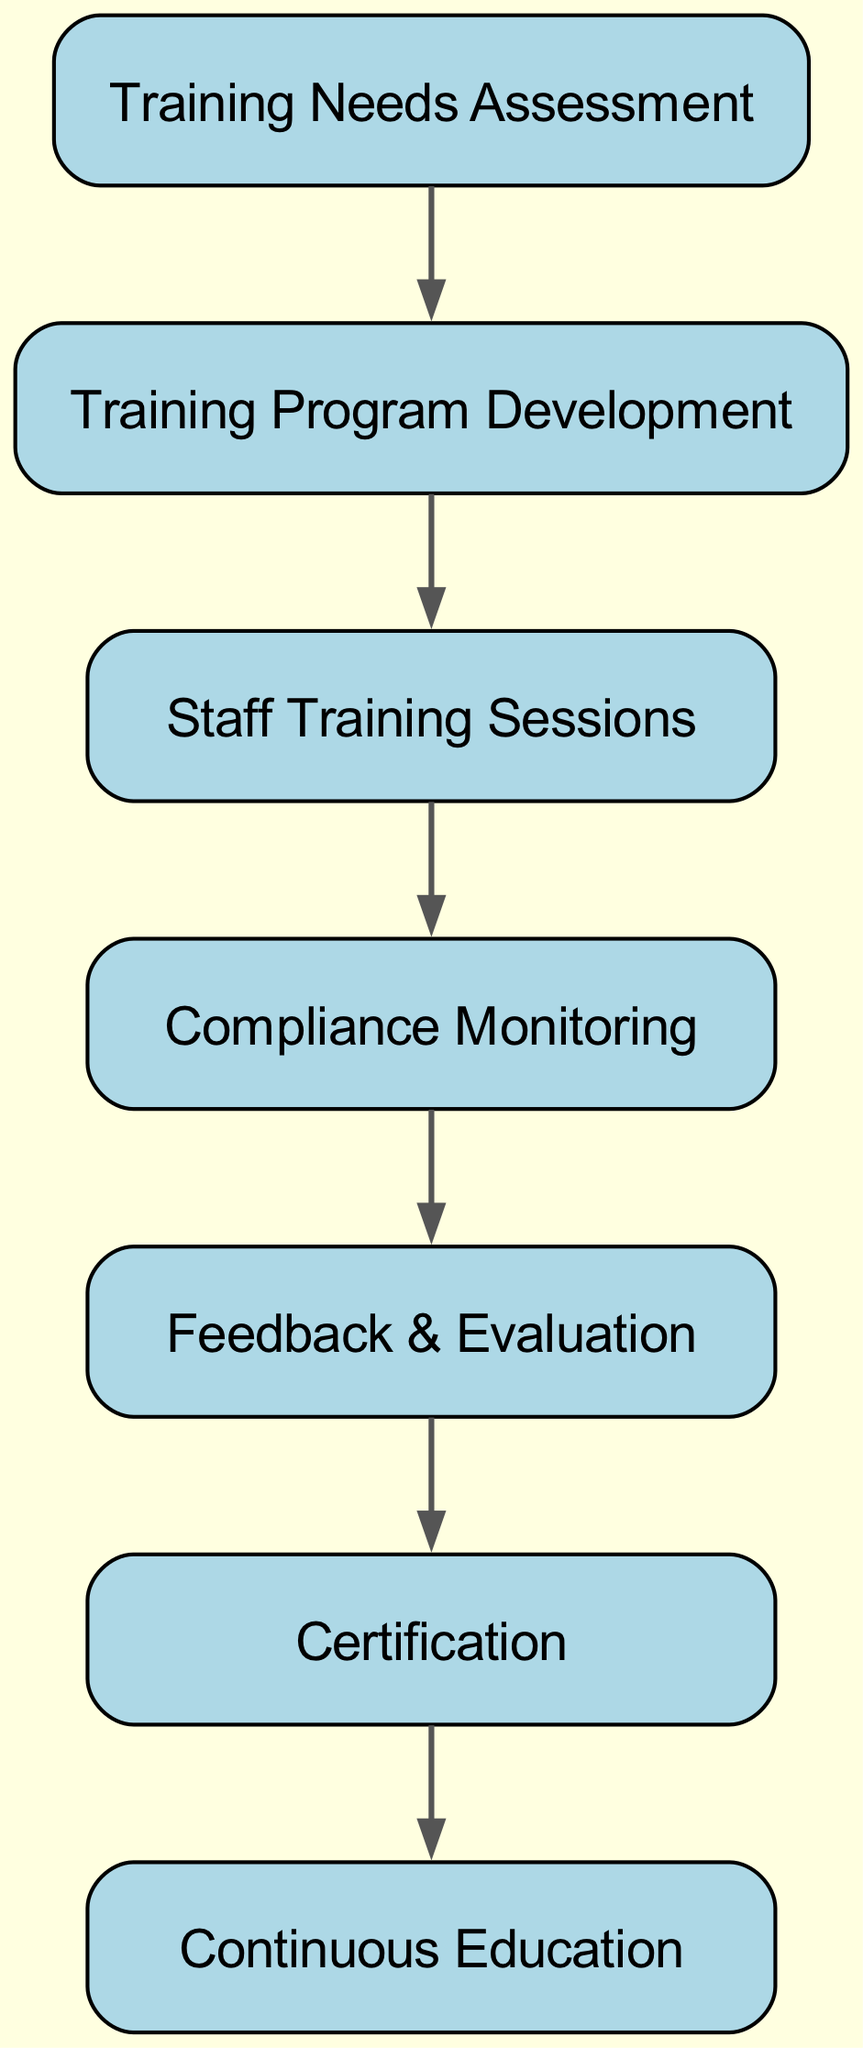What is the first step in the workflow? The first step indicated in the directed graph is "Training Needs Assessment." It is represented as the initial node from which the workflow begins.
Answer: Training Needs Assessment How many nodes are in the diagram? The diagram contains a total of 7 distinct nodes representing different stages in the training and compliance workflow.
Answer: 7 What follows "Staff Training Sessions" in the workflow? The node that follows "Staff Training Sessions" is "Compliance Monitoring," which directly connects to it, indicating the next stage of the process.
Answer: Compliance Monitoring Which node is the final outcome of the workflow? The final outcome of the workflow is "Continuous Education," which is connected to the "Certification" node, and there are no further nodes linked after it.
Answer: Continuous Education What is the relationship between "Feedback & Evaluation" and "Certification"? The relationship is that "Feedback & Evaluation" directly leads to "Certification" as its next step, indicating that the evaluation process must precede certification.
Answer: Direct Which nodes are connected directly to "Training Program Development"? "Training Program Development" is directly connected to "Staff Training Sessions" as the next step in the workflow, indicating its immediate output.
Answer: Staff Training Sessions How many edges are present in the diagram? The diagram consists of 6 edges, each representing a directed connection from one node to another in the workflow.
Answer: 6 What is the sequential order of the workflow starting from "Training Needs Assessment"? The sequence is as follows: "Training Needs Assessment" leads to "Training Program Development," which then leads to "Staff Training Sessions," followed by "Compliance Monitoring," then "Feedback & Evaluation," culminating in "Certification," and finally "Continuous Education."
Answer: Training Needs Assessment → Training Program Development → Staff Training Sessions → Compliance Monitoring → Feedback & Evaluation → Certification → Continuous Education 